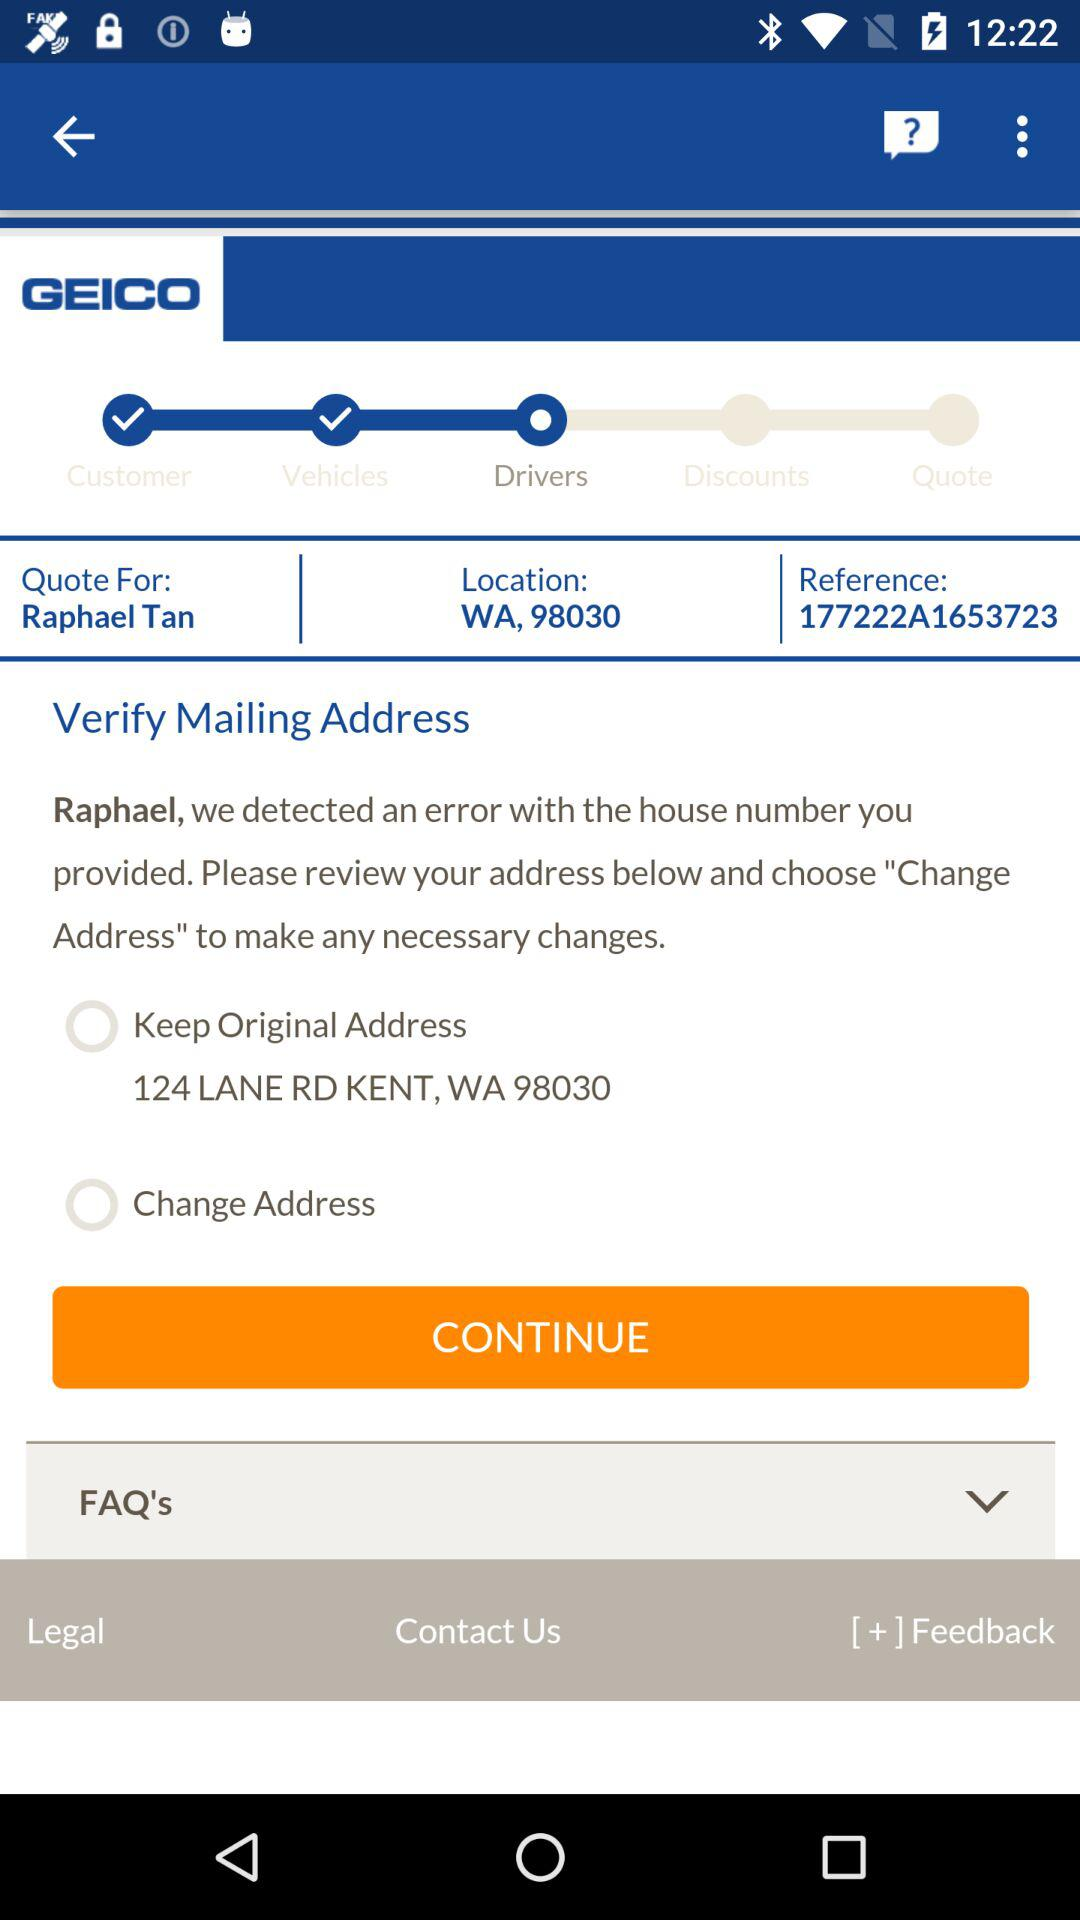What is the location? The location is WA, 98030. 